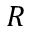<formula> <loc_0><loc_0><loc_500><loc_500>R</formula> 